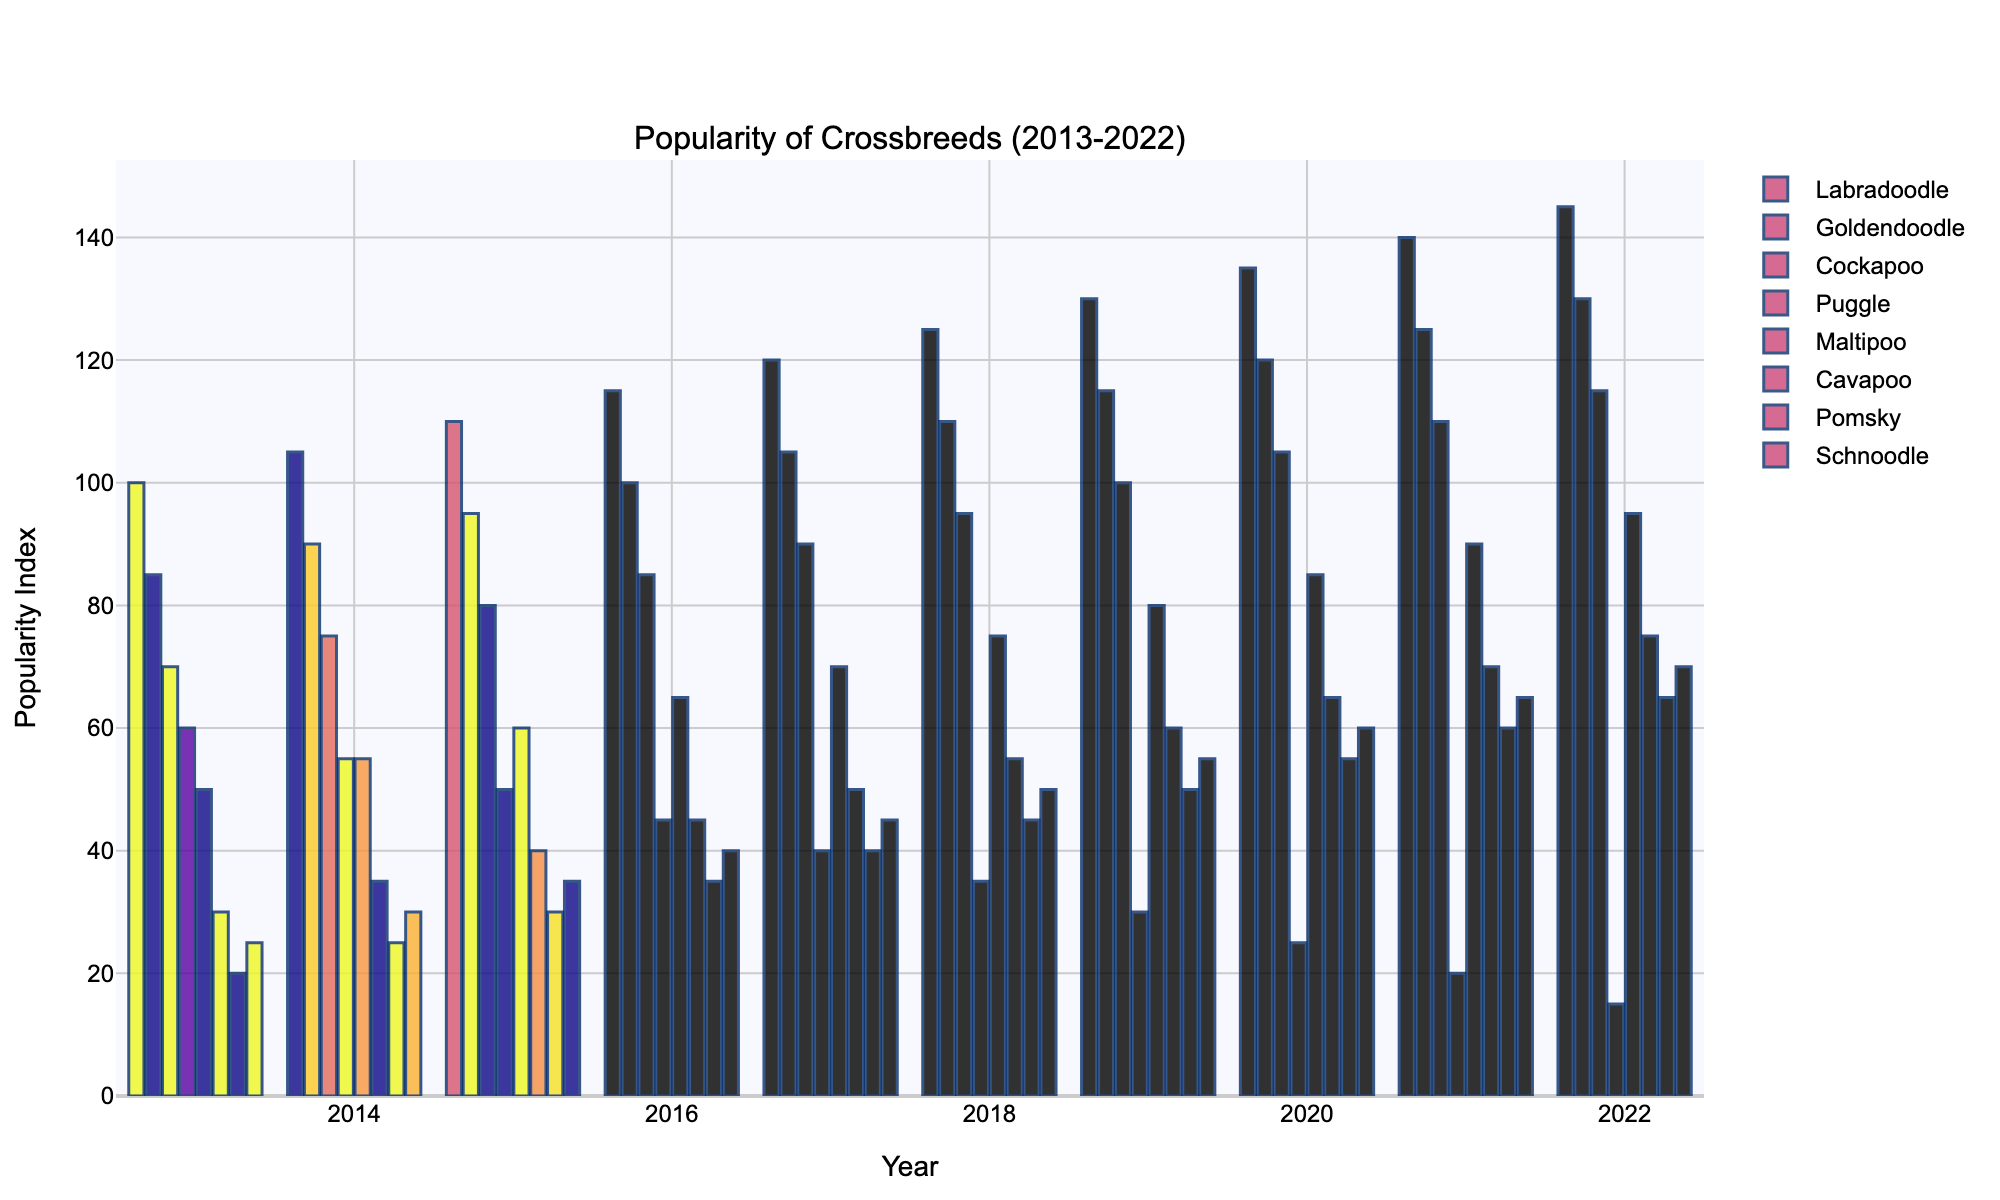Which crossbreed had the highest popularity in 2022? In 2022, looking at the height of the bars, Labradoodle has the tallest bar. This indicates it had the highest popularity among the listed crossbreeds.
Answer: Labradoodle How did the popularity of the Puggle change from 2013 to 2022? To determine the change in popularity, subtract the 2022 value from the 2013 value for Puggle. This is 15 (2022) - 60 (2013) = -45. This indicates a decrease in popularity.
Answer: Decreased by 45 Which crossbreed showed a continuous increase in popularity each year? By visually inspecting the bars for each year, only Labradoodle consistently shows a taller bar each subsequent year.
Answer: Labradoodle Between Goldendoodle and Pomsky, which had a larger increase in popularity from 2013 to 2022? Subtract the 2013 popularity index from the 2022 index for both breeds: Goldendoodle (130-85=45) and Pomsky (65-20=45). Both have the same increase.
Answer: Both increased by 45 Which year did Maltipoo surpass Cockapoo in popularity? By comparing the bar heights for Maltipoo and Cockapoo over each year, in 2015, Maltipoo's bar height (60) exceeds Cockapoo’s (50) for the first time.
Answer: 2015 What is the total popularity index for Cavapoo over the decade? Sum the popularity indices for Cavapoo from 2013 to 2022: 30 + 35 + 40 + 45 + 50 + 55 + 60 + 65 + 70 = 450.
Answer: 450 Which breed had the smallest increase in popularity over the decade? Calculate the increase for each breed: 
- Labradoodle: 145-100=45
- Goldendoodle: 130-85=45
- Cockapoo: 115-70=45
- Puggle: 15-60=-45
For Puggle, the increase is negative, indicating the smallest increase since it's actually a decrease.
Answer: Puggle In which year did Pomsky first exceed a popularity index of 50? Check the bars for Pomsky and find the first year where the bar height is above 50. This happens in 2019 when the popularity index reaches 50.
Answer: 2019 Which crossbreed had the lowest popularity in 2015, and what was its popularity index that year? Look at the bars in 2015, and the shortest corresponds to Schnoodle with a popularity index of 35.
Answer: Schnoodle, 35 